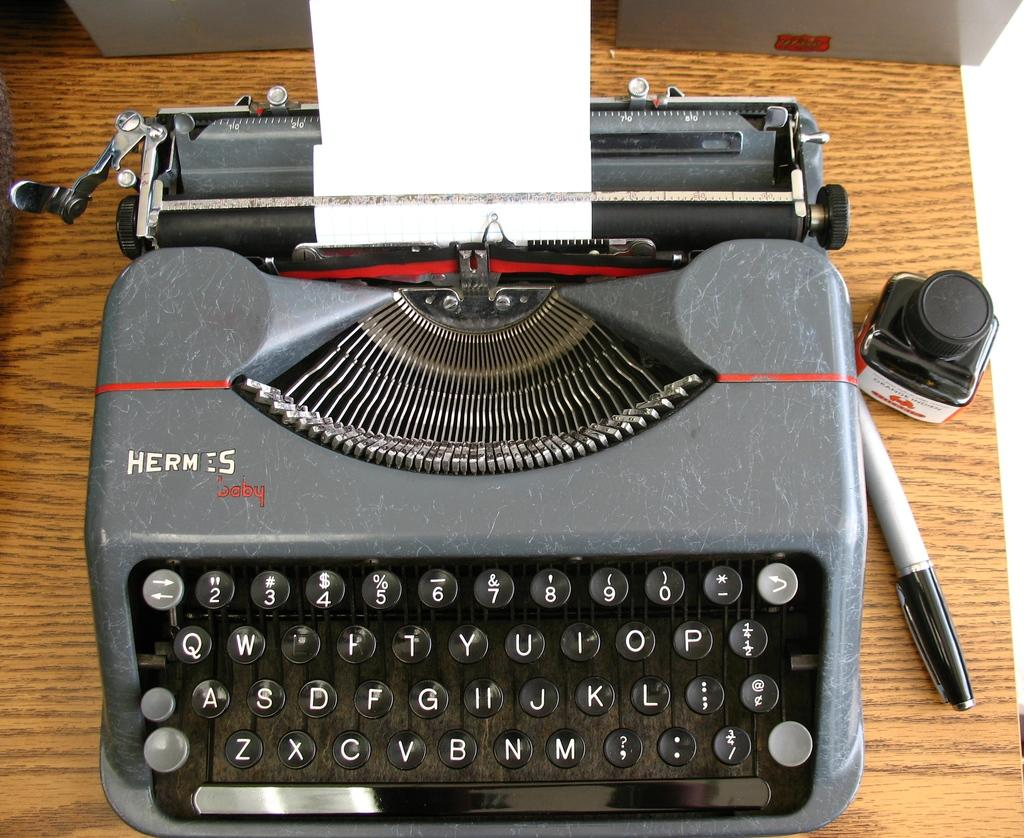<image>
Summarize the visual content of the image. A Hermes brand typewriter sits on a table. 